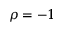Convert formula to latex. <formula><loc_0><loc_0><loc_500><loc_500>\rho = - 1</formula> 